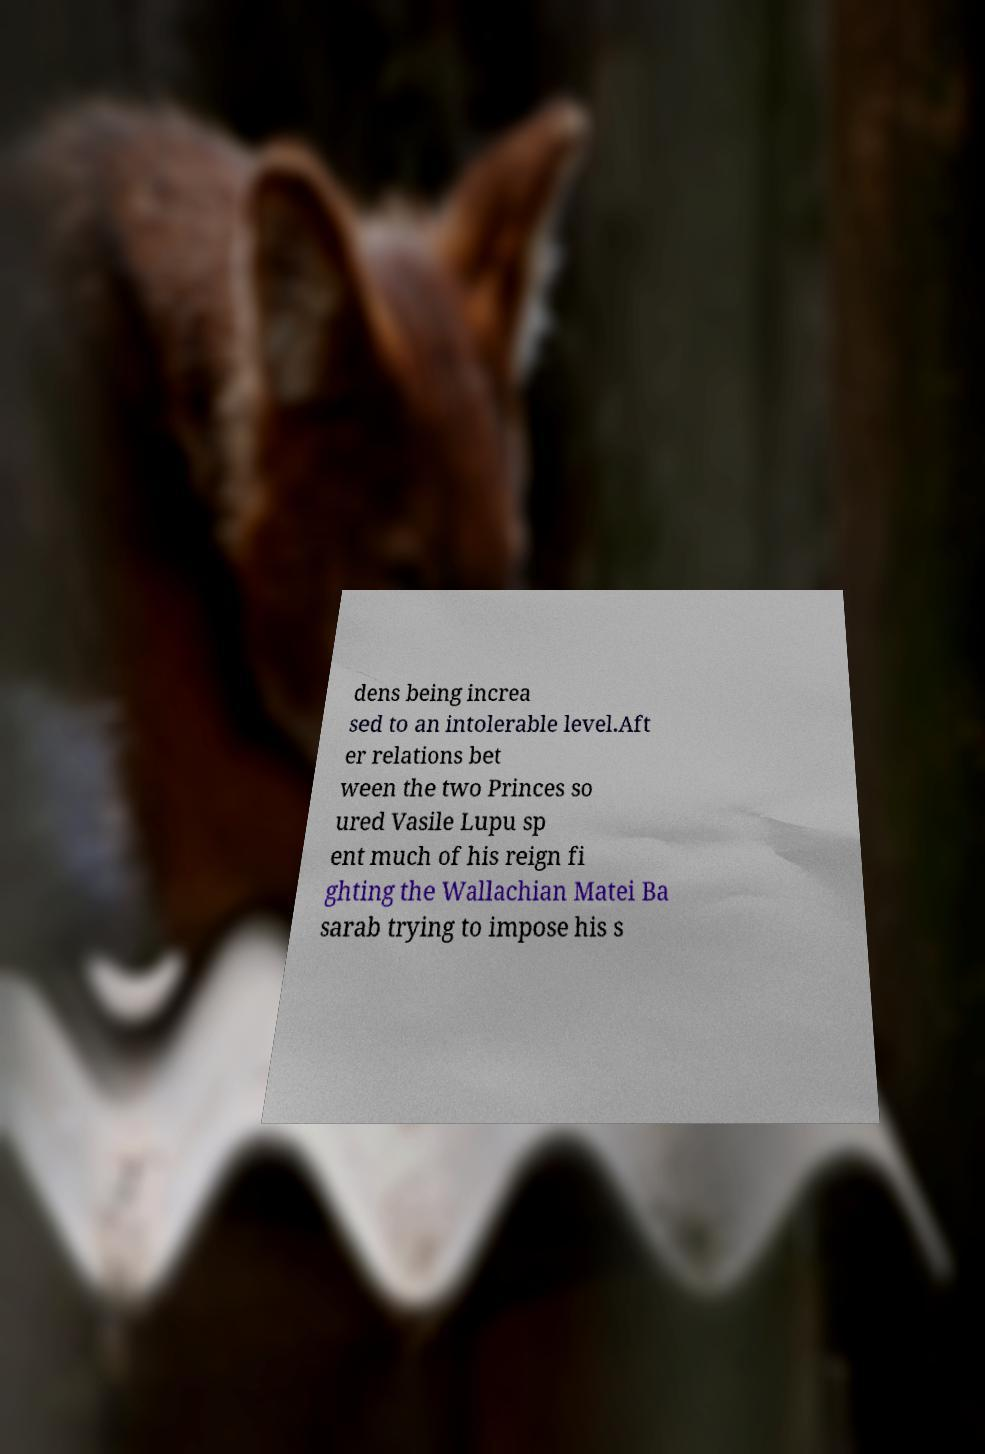Could you extract and type out the text from this image? dens being increa sed to an intolerable level.Aft er relations bet ween the two Princes so ured Vasile Lupu sp ent much of his reign fi ghting the Wallachian Matei Ba sarab trying to impose his s 